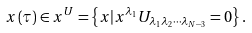Convert formula to latex. <formula><loc_0><loc_0><loc_500><loc_500>x \left ( \tau \right ) \in x ^ { U } = \left \{ x | x ^ { \lambda _ { 1 } } U _ { \lambda _ { 1 } \lambda _ { 2 } \cdots \lambda _ { N - 3 } } = 0 \right \} .</formula> 